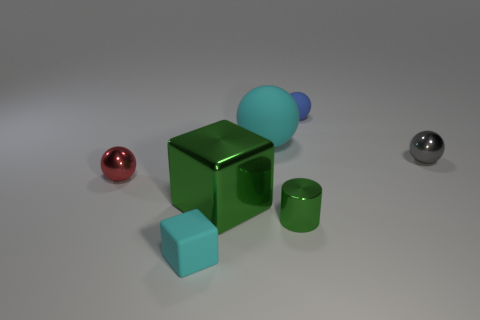Is there any other thing that has the same shape as the tiny green thing?
Offer a very short reply. No. What number of things are either big purple cylinders or tiny rubber things that are in front of the tiny green metallic thing?
Your answer should be very brief. 1. There is a rubber thing in front of the tiny gray shiny thing; how big is it?
Provide a succinct answer. Small. Are there fewer blue things that are right of the tiny gray metal sphere than tiny blue spheres that are right of the large cyan rubber sphere?
Offer a very short reply. Yes. What is the small sphere that is both in front of the small rubber sphere and on the right side of the small red metal thing made of?
Offer a terse response. Metal. What shape is the cyan thing behind the cube in front of the cylinder?
Offer a very short reply. Sphere. Do the big rubber thing and the rubber block have the same color?
Provide a short and direct response. Yes. What number of red things are cylinders or tiny metallic things?
Provide a succinct answer. 1. There is a red shiny ball; are there any tiny gray things behind it?
Offer a very short reply. Yes. What is the size of the green cylinder?
Your answer should be compact. Small. 